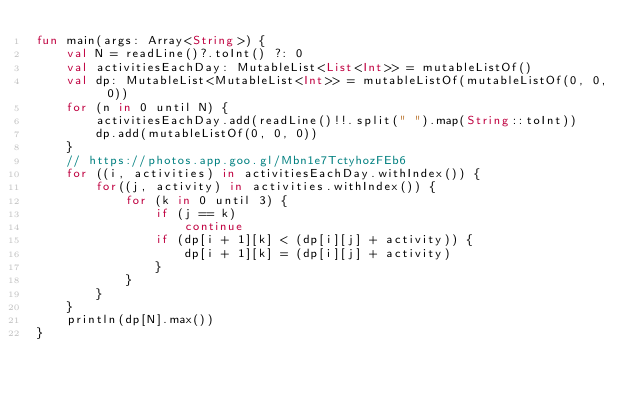Convert code to text. <code><loc_0><loc_0><loc_500><loc_500><_Kotlin_>fun main(args: Array<String>) {
    val N = readLine()?.toInt() ?: 0
    val activitiesEachDay: MutableList<List<Int>> = mutableListOf()
    val dp: MutableList<MutableList<Int>> = mutableListOf(mutableListOf(0, 0, 0))
    for (n in 0 until N) {
        activitiesEachDay.add(readLine()!!.split(" ").map(String::toInt))
        dp.add(mutableListOf(0, 0, 0))
    }
    // https://photos.app.goo.gl/Mbn1e7TctyhozFEb6
    for ((i, activities) in activitiesEachDay.withIndex()) {
        for((j, activity) in activities.withIndex()) {
            for (k in 0 until 3) {
                if (j == k)
                    continue
                if (dp[i + 1][k] < (dp[i][j] + activity)) {
                    dp[i + 1][k] = (dp[i][j] + activity)
                }
            }
        }
    }
    println(dp[N].max())
}</code> 